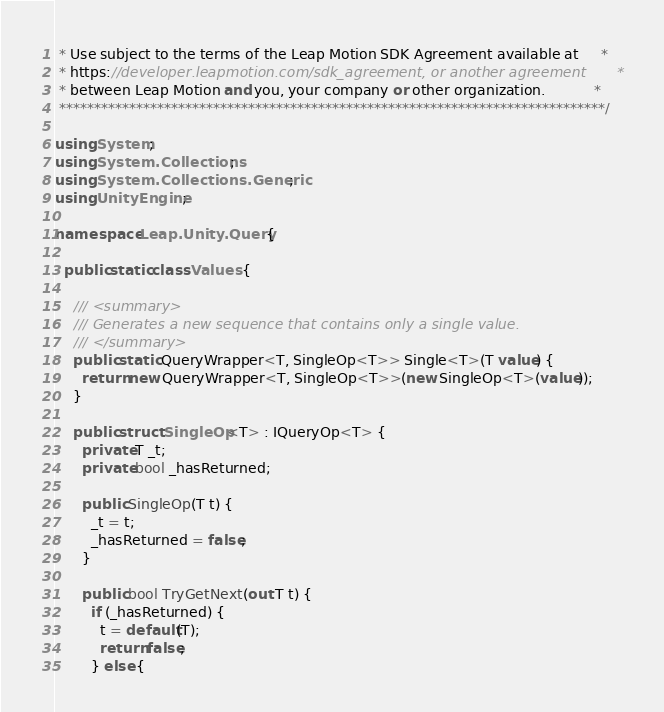Convert code to text. <code><loc_0><loc_0><loc_500><loc_500><_C#_> * Use subject to the terms of the Leap Motion SDK Agreement available at     *
 * https://developer.leapmotion.com/sdk_agreement, or another agreement       *
 * between Leap Motion and you, your company or other organization.           *
 ******************************************************************************/

using System;
using System.Collections;
using System.Collections.Generic;
using UnityEngine;

namespace Leap.Unity.Query {

  public static class Values {

    /// <summary>
    /// Generates a new sequence that contains only a single value.
    /// </summary>
    public static QueryWrapper<T, SingleOp<T>> Single<T>(T value) {
      return new QueryWrapper<T, SingleOp<T>>(new SingleOp<T>(value));
    }

    public struct SingleOp<T> : IQueryOp<T> {
      private T _t;
      private bool _hasReturned;

      public SingleOp(T t) {
        _t = t;
        _hasReturned = false;
      }

      public bool TryGetNext(out T t) {
        if (_hasReturned) {
          t = default(T);
          return false;
        } else {</code> 